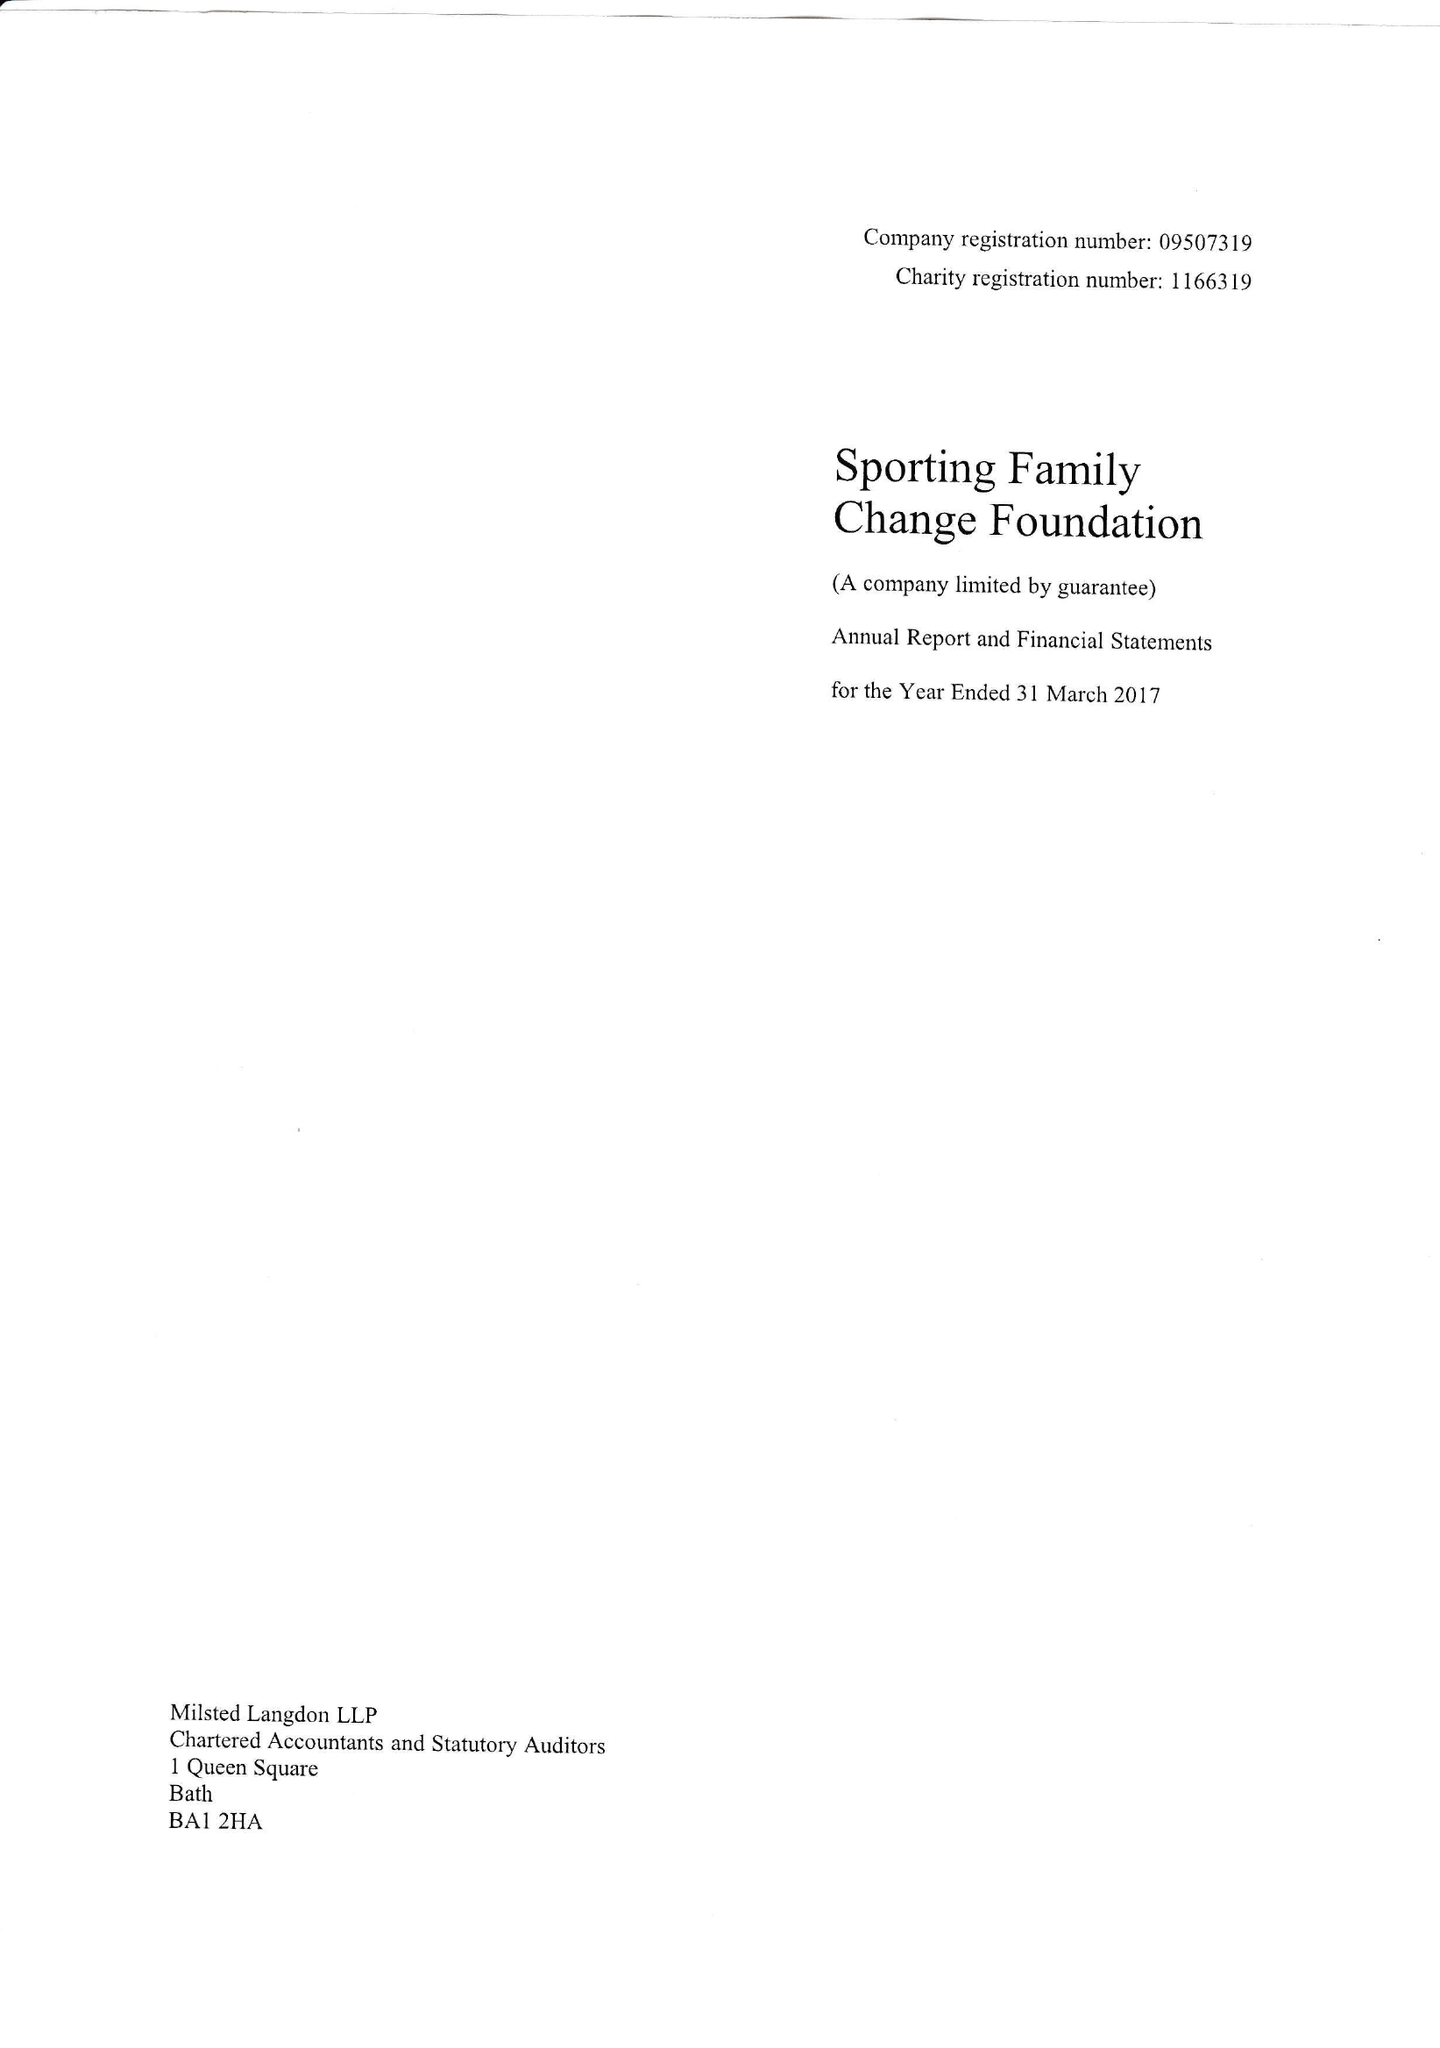What is the value for the address__postcode?
Answer the question using a single word or phrase. BA2 7AG 